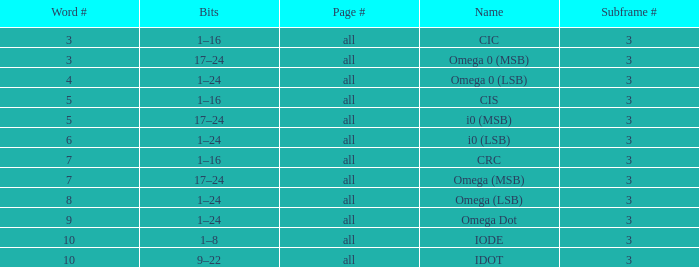What is the total word count with a subframe count greater than 3? None. 